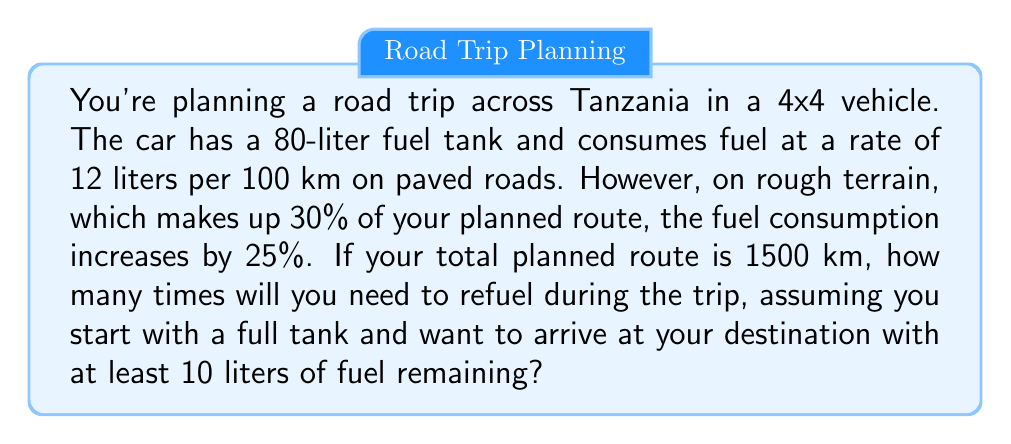Could you help me with this problem? Let's approach this step-by-step:

1. Calculate the fuel consumption on paved roads:
   70% of 1500 km = $0.7 \times 1500 = 1050$ km
   Fuel used = $1050 \times \frac{12}{100} = 126$ liters

2. Calculate the fuel consumption on rough terrain:
   30% of 1500 km = $0.3 \times 1500 = 450$ km
   Increased consumption rate = $12 \times 1.25 = 15$ liters per 100 km
   Fuel used = $450 \times \frac{15}{100} = 67.5$ liters

3. Calculate total fuel consumption:
   Total fuel = $126 + 67.5 = 193.5$ liters

4. Calculate the number of full tanks needed:
   Usable fuel capacity = $80 - 10 = 70$ liters (accounting for the 10 liters reserve)
   Number of tanks = $\frac{193.5}{70} \approx 2.76$

5. Round up to the nearest whole number:
   Number of refuels needed = 3

Therefore, you will need to refuel 3 times during the trip to ensure you have at least 10 liters remaining at the destination.
Answer: 3 refuels 